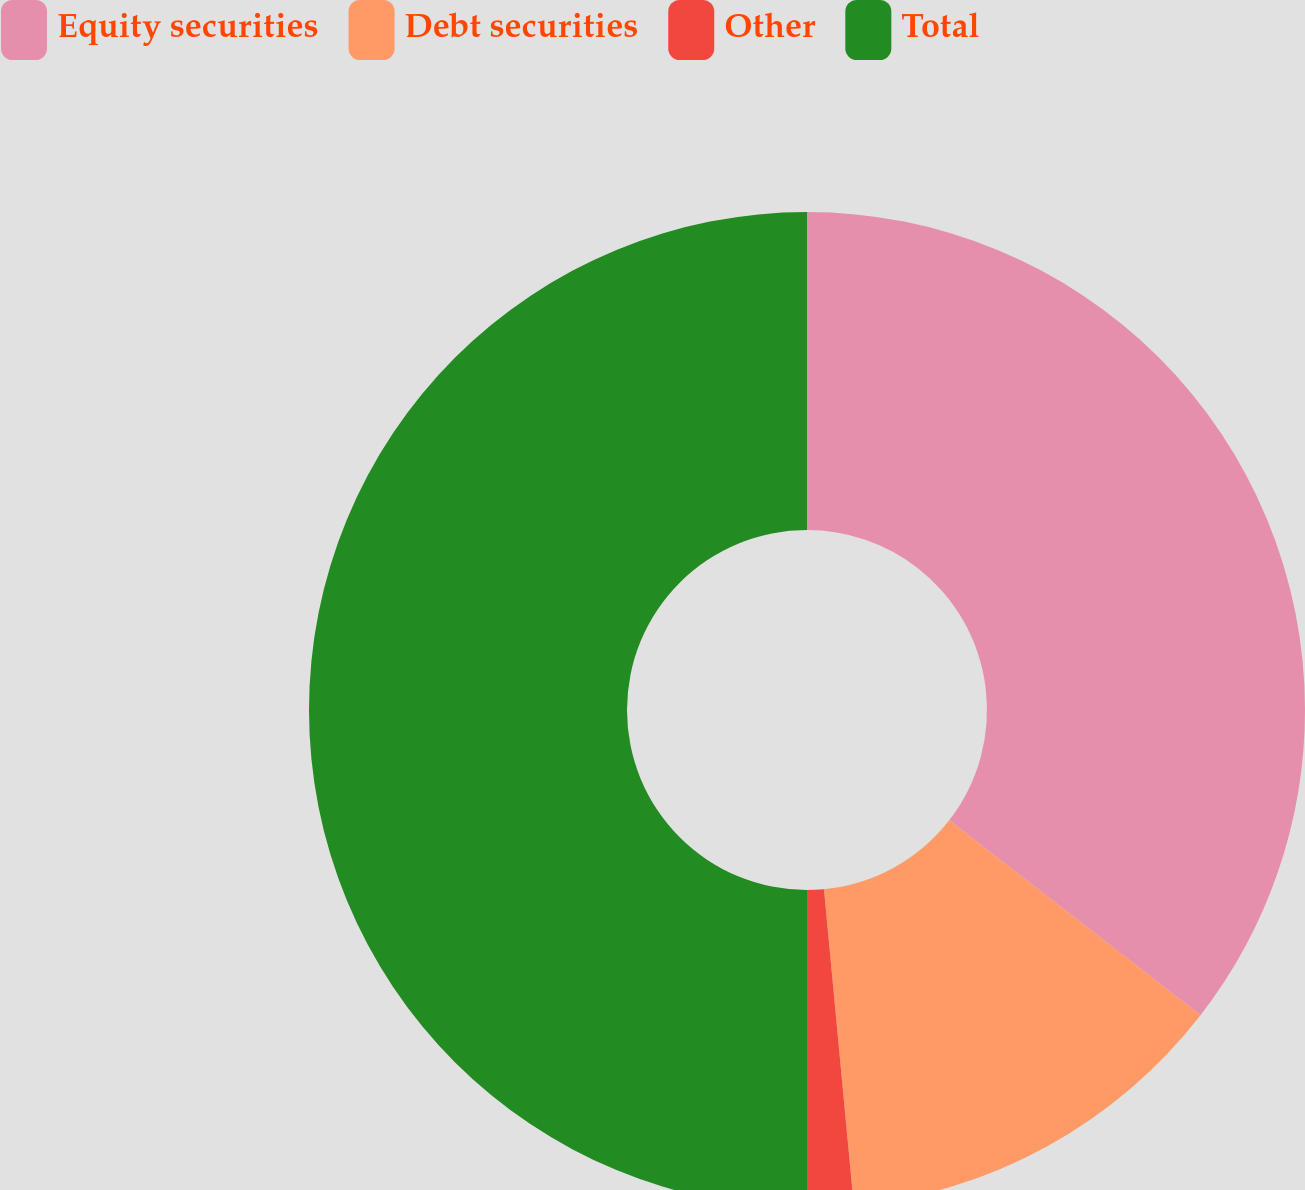Convert chart. <chart><loc_0><loc_0><loc_500><loc_500><pie_chart><fcel>Equity securities<fcel>Debt securities<fcel>Other<fcel>Total<nl><fcel>35.5%<fcel>13.0%<fcel>1.5%<fcel>50.0%<nl></chart> 